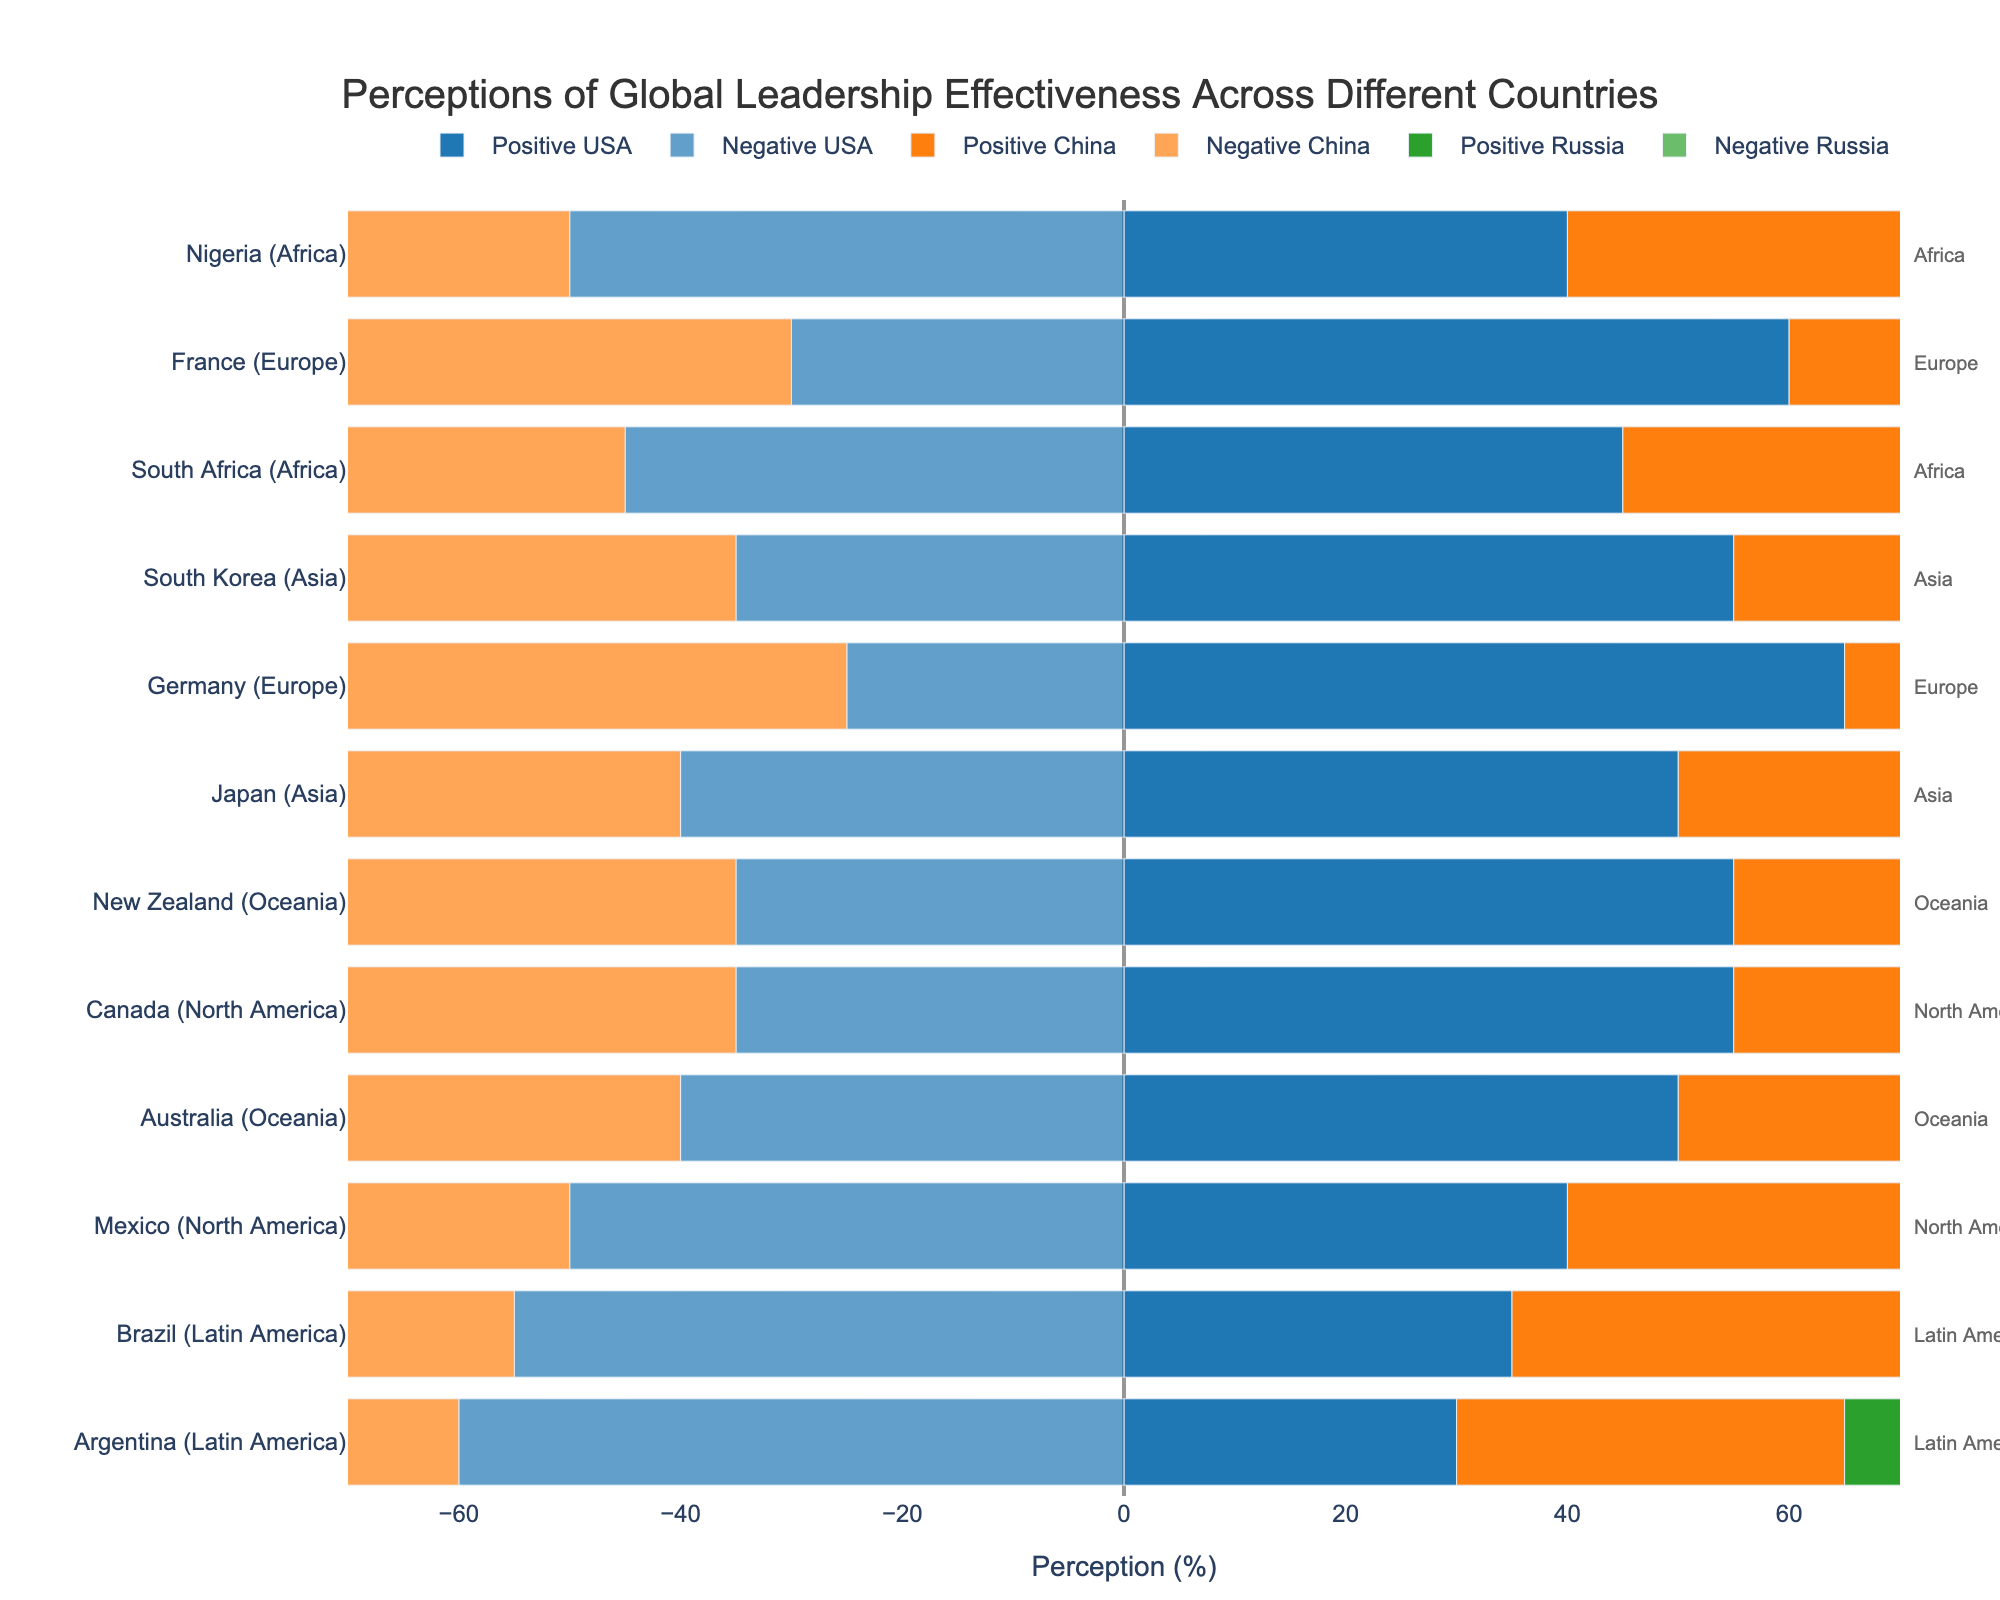Which country has the highest positive perception of the USA? The countries are categorized by their regions. By looking at the positive perception values for the USA across all countries, Germany has the highest positive perception with 65%.
Answer: Germany Compare the negative perceptions of Russia and China across Latin America. Which country shows a higher negative perception for each leader? In Brazil, the negative perception of Russia is higher at 60% compared to China's 50%. In Argentina, Russia's negative perception is 65%, while China's is 55%. Thus, Russia has a higher negative perception in both Brazil and Argentina.
Answer: Russia What is the difference in positive perception of China between South Africa and Nigeria? Positive perception of China in South Africa is 50%, while in Nigeria, it is 55%. The difference is calculated as 55% - 50% = 5%.
Answer: 5% Which region has the highest negative perception of Russia? By looking at the different country values and their respective regions, Latin American country Argentina has the highest negative perception at 65%.
Answer: Latin America Compare the total positive perception (sum) of the USA in North America to Europe. Which is higher and by how much? In North America, Canada has 55% and Mexico 40%, summing to 95%. In Europe, Germany has 65% and France 60%, summing to 125%. The difference is 125% - 95% = 30%. Hence, Europe is higher by 30%.
Answer: Europe, 30% Which country in Oceania shows the higher positive perception for USA, and what is the difference between the two countries? In Oceania, Australia has a positive perception of 50% for USA, and New Zealand has 55%. The difference is calculated as 55% - 50% = 5%.
Answer: New Zealand, 5% Compare the negative perceptions of USA and Russia in Canada. Which is higher and by how much? In Canada, the negative perception is 35% for USA and 55% for Russia. The difference is calculated as 55% - 35% = 20%.
Answer: Russia, 20% What is the average negative perception of China in North America? In North America, Mexico has a negative perception of 45%, and Canada has 50%. The average is calculated as (45 + 50) / 2 = 47.5%.
Answer: 47.5% Which region has the greater variance in positive perceptions of China among its countries? Variance measures the spread of values. For North America, Canada and Mexico have values of 30% and 35%, respectively, resulting in a lower variance. For Europe, Germany has 30% and France 35% (similarly low variance). In Africa, South Africa has 50% and Nigeria 55%, calculated variance is somewhat more. Comparing these variances through examination reveals that Africa shows a greater spread with values ranging from 50% to 55%.
Answer: Africa Which country has almost equal positive and negative perceptions of the USA? By inspecting the figure, South Africa shows equal positive and negative perceptions, both at 45%.
Answer: South Africa 